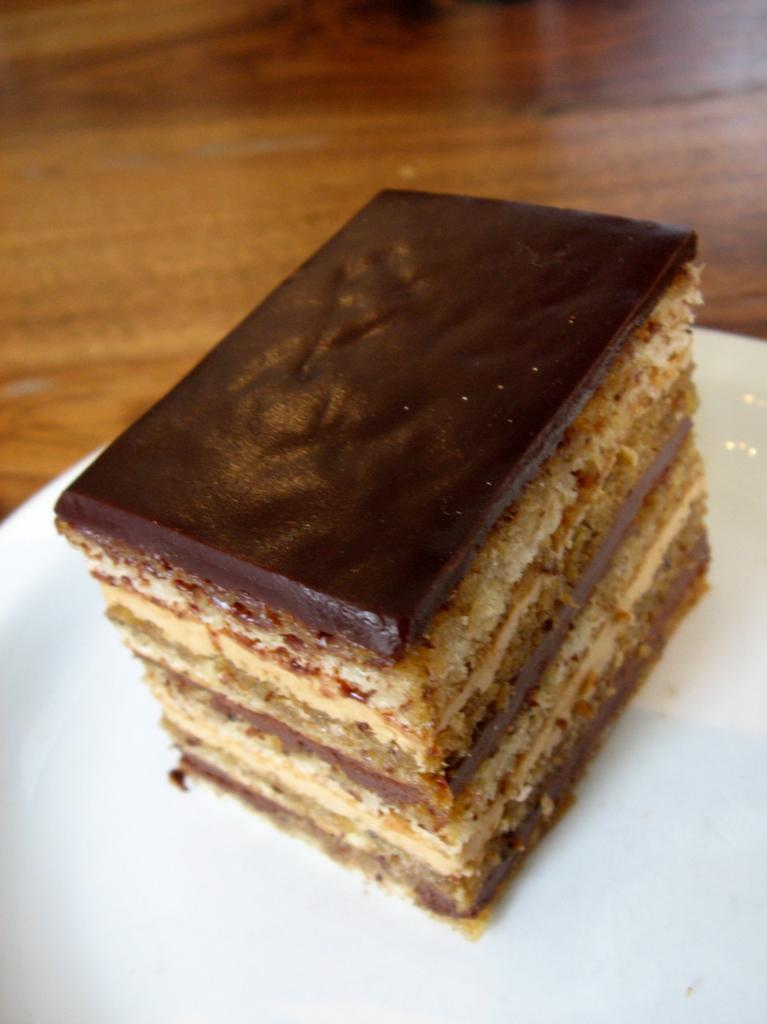What is the main subject of the image? There is a cake in the image. How is the cake positioned in the image? The cake is on a plate. Is the cake on any other surface in the image? Yes, the plate is placed on a platform. What type of crow is observing the teaching session in the image? There is no crow or teaching session present in the image; it features a cake on a plate placed on a platform. 